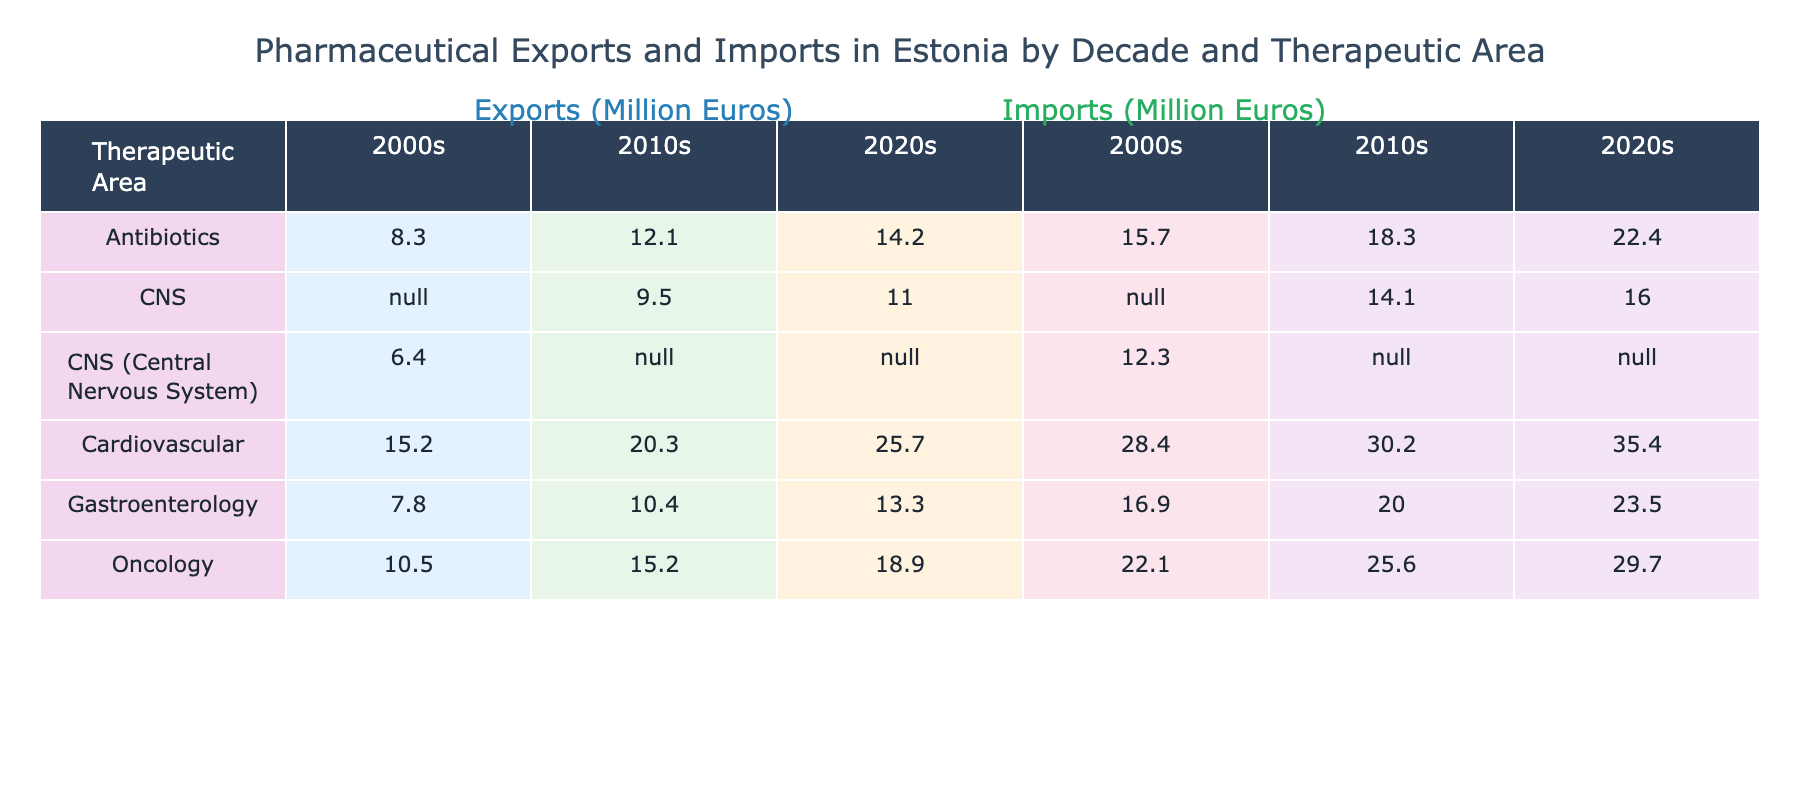What were the pharmaceutical imports for Gastroenterology in the 2010s? From the table, under the therapeutic area "Gastroenterology" for the 2010s column, the value listed for pharmaceutical imports is 20.0 million Euros.
Answer: 20.0 million Euros Which therapeutic area had the highest exports in the 2020s? By comparing the export values for each therapeutic area in the 2020s, "Cardiovascular" had the highest value at 25.7 million Euros.
Answer: Cardiovascular What is the total pharmaceutical export value for Antibiotics across all decades? The export values for Antibiotics are 8.3 (2000s) + 12.1 (2010s) + 14.2 (2020s) = 34.6 million Euros.
Answer: 34.6 million Euros Did the total pharmaceutical imports for Oncology increase or decrease from the 2000s to the 2020s? The imports for Oncology were 22.1 million Euros in the 2000s and increased to 29.7 million Euros in the 2020s. Therefore, it increased.
Answer: Increased What was the average pharmaceutical import value for the CNS therapeutic area across all decades? The import values for CNS are 12.3 (2000s) + 14.1 (2010s) + 16.0 (2020s) = 42.4 million Euros. To find the average, divide by 3 (the number of decades): 42.4 / 3 = 14.13 million Euros.
Answer: 14.13 million Euros How much more did Estonia import pharmaceuticals for Cardiovascular compared to Oncology in the 2010s? In the 2010s, imports for Cardiovascular are 30.2 million Euros and for Oncology are 25.6 million Euros. The difference is 30.2 - 25.6 = 4.6 million Euros.
Answer: 4.6 million Euros Which decade saw the least imports for Gastroenterology? By looking at the data, the total imports for Gastroenterology are 16.9 million Euros in the 2000s, 20.0 million Euros in the 2010s, and 23.5 million Euros in the 2020s. Thus, the 2000s had the least imports.
Answer: 2000s Check if total pharmaceutical exports in the 2020s exceeded total pharmaceutical imports in the 2020s. The total exports in the 2020s = 25.7 (Cardiovascular) + 18.9 (Oncology) + 14.2 (Antibiotics) + 11.0 (CNS) + 13.3 (Gastroenterology) = 83.1 million Euros. The total imports for the 2020s = 35.4 + 29.7 + 22.4 + 16.0 + 23.5 = 126.0 million Euros. Since 83.1 < 126.0, exports did not exceed imports.
Answer: No 